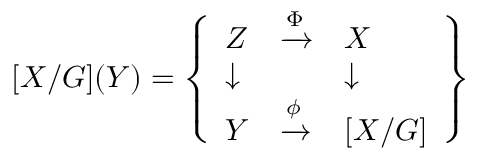<formula> <loc_0><loc_0><loc_500><loc_500>[ X / G ] ( Y ) = { \left \{ \begin{array} { l l l } { Z } & { { \xrightarrow { \Phi } } } & { X } \\ { \downarrow } & { \downarrow } \\ { Y } & { { \xrightarrow { \phi } } } & { [ X / G ] } \end{array} \right \} }</formula> 